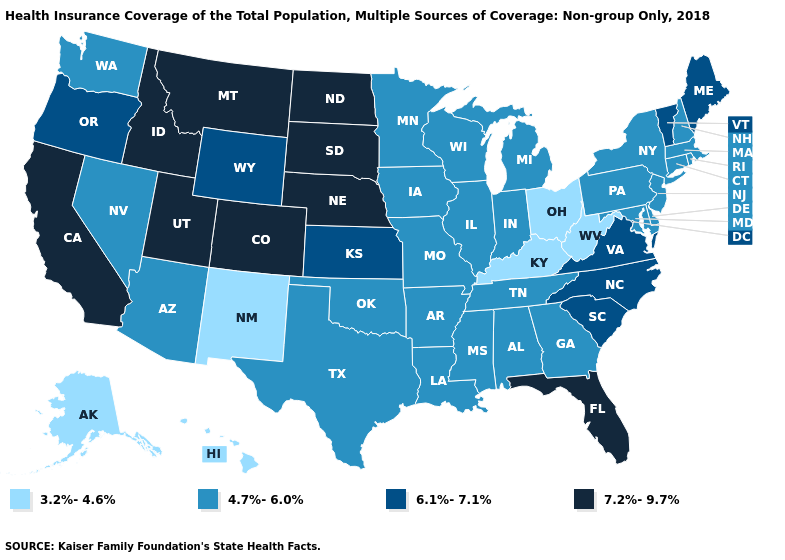Does Nebraska have the highest value in the USA?
Be succinct. Yes. Name the states that have a value in the range 6.1%-7.1%?
Keep it brief. Kansas, Maine, North Carolina, Oregon, South Carolina, Vermont, Virginia, Wyoming. Among the states that border Pennsylvania , which have the highest value?
Be succinct. Delaware, Maryland, New Jersey, New York. What is the lowest value in the USA?
Write a very short answer. 3.2%-4.6%. Name the states that have a value in the range 6.1%-7.1%?
Keep it brief. Kansas, Maine, North Carolina, Oregon, South Carolina, Vermont, Virginia, Wyoming. Does Arizona have the lowest value in the USA?
Concise answer only. No. What is the value of Hawaii?
Short answer required. 3.2%-4.6%. Which states hav the highest value in the West?
Write a very short answer. California, Colorado, Idaho, Montana, Utah. Name the states that have a value in the range 6.1%-7.1%?
Be succinct. Kansas, Maine, North Carolina, Oregon, South Carolina, Vermont, Virginia, Wyoming. What is the lowest value in the West?
Answer briefly. 3.2%-4.6%. How many symbols are there in the legend?
Concise answer only. 4. Which states hav the highest value in the Northeast?
Answer briefly. Maine, Vermont. Does New York have the lowest value in the Northeast?
Concise answer only. Yes. What is the value of New Mexico?
Quick response, please. 3.2%-4.6%. What is the lowest value in states that border Montana?
Short answer required. 6.1%-7.1%. 